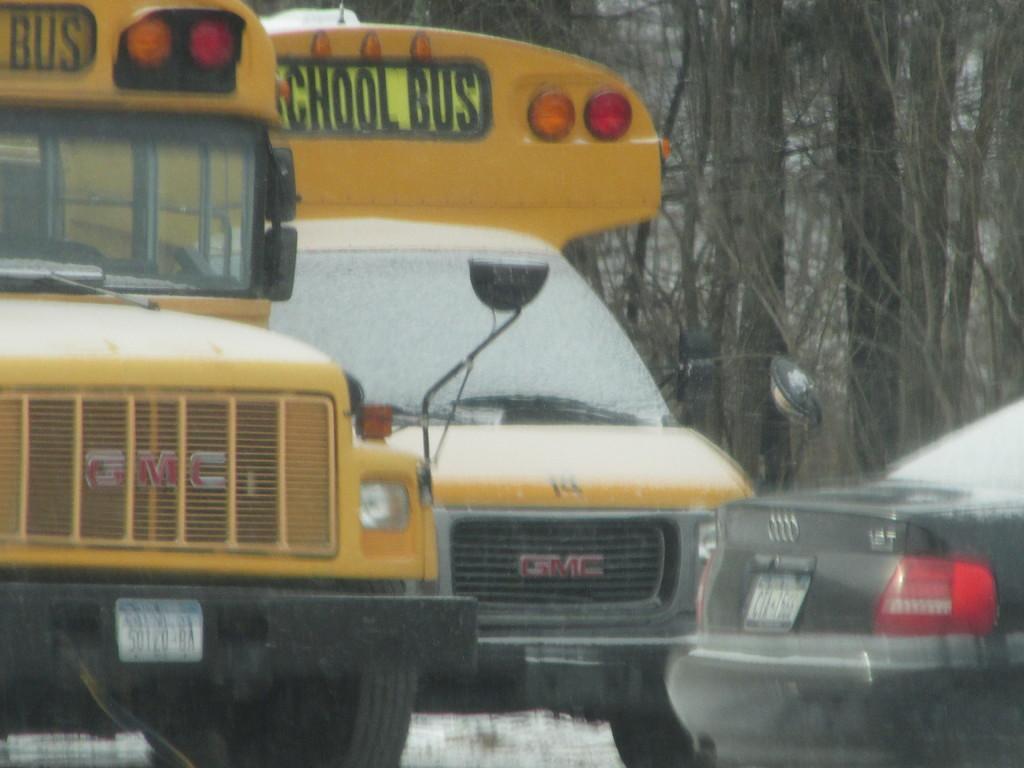Can you describe this image briefly? In this picture we can see there are three vehicles. Behind the vehicles, there are trees. 